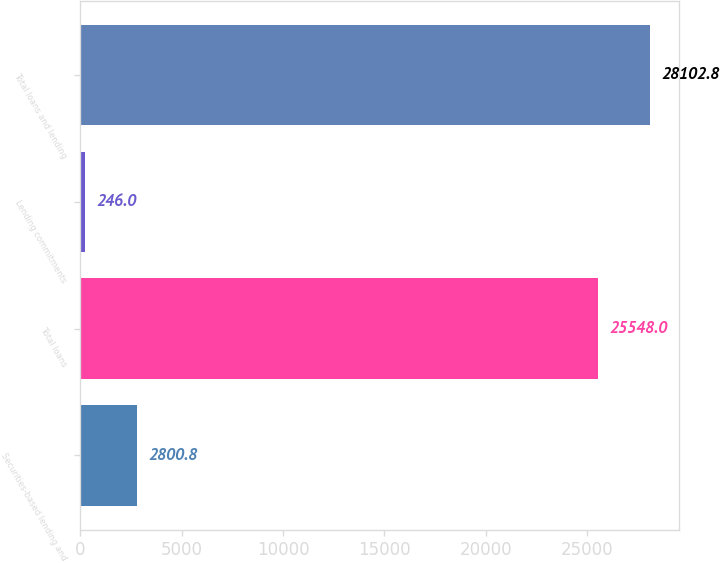Convert chart. <chart><loc_0><loc_0><loc_500><loc_500><bar_chart><fcel>Securities-based lending and<fcel>Total loans<fcel>Lending commitments<fcel>Total loans and lending<nl><fcel>2800.8<fcel>25548<fcel>246<fcel>28102.8<nl></chart> 